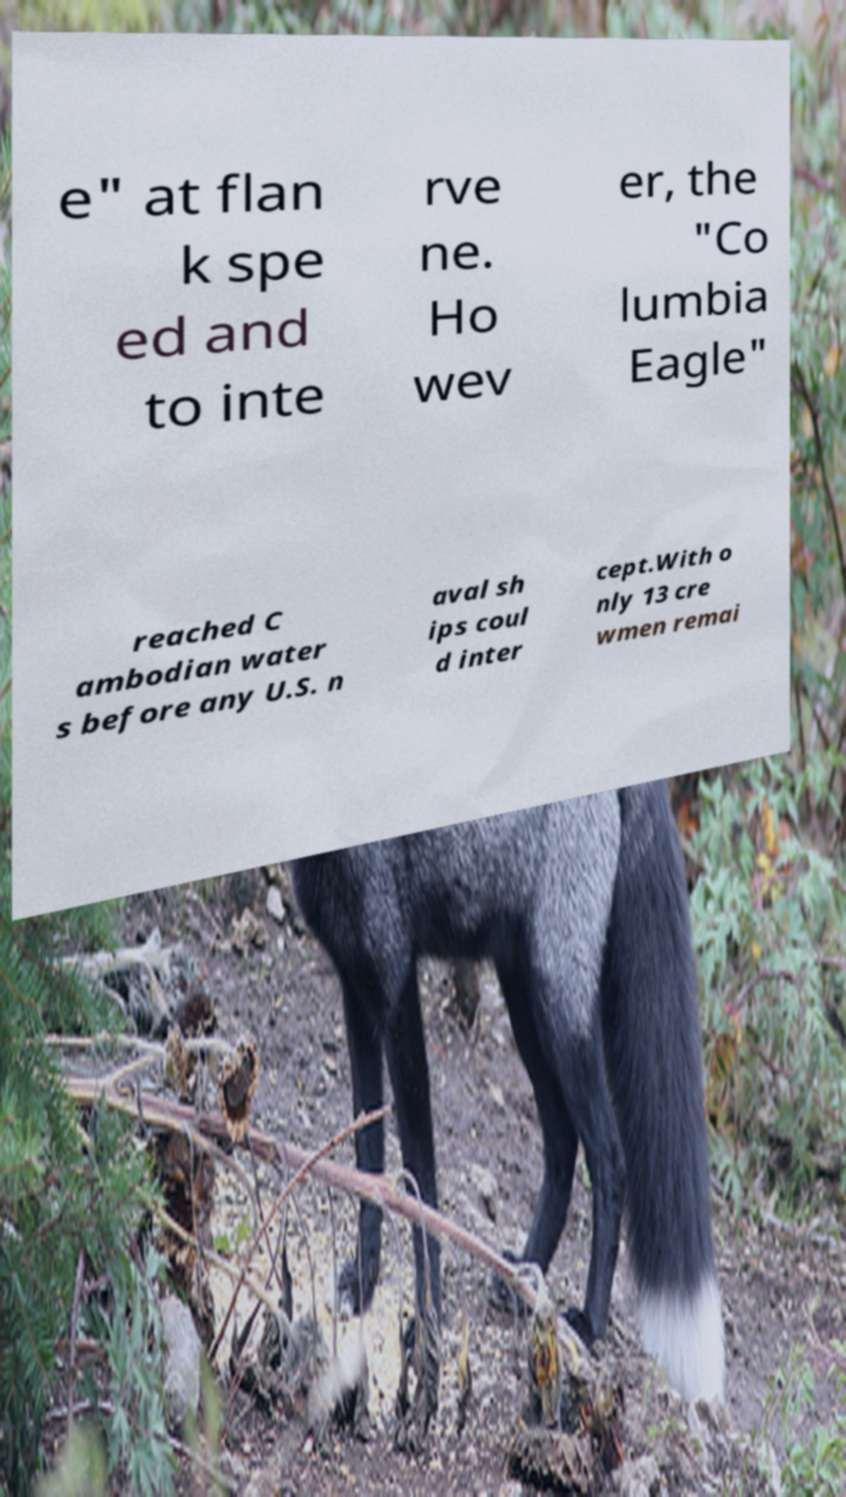Could you assist in decoding the text presented in this image and type it out clearly? e" at flan k spe ed and to inte rve ne. Ho wev er, the "Co lumbia Eagle" reached C ambodian water s before any U.S. n aval sh ips coul d inter cept.With o nly 13 cre wmen remai 